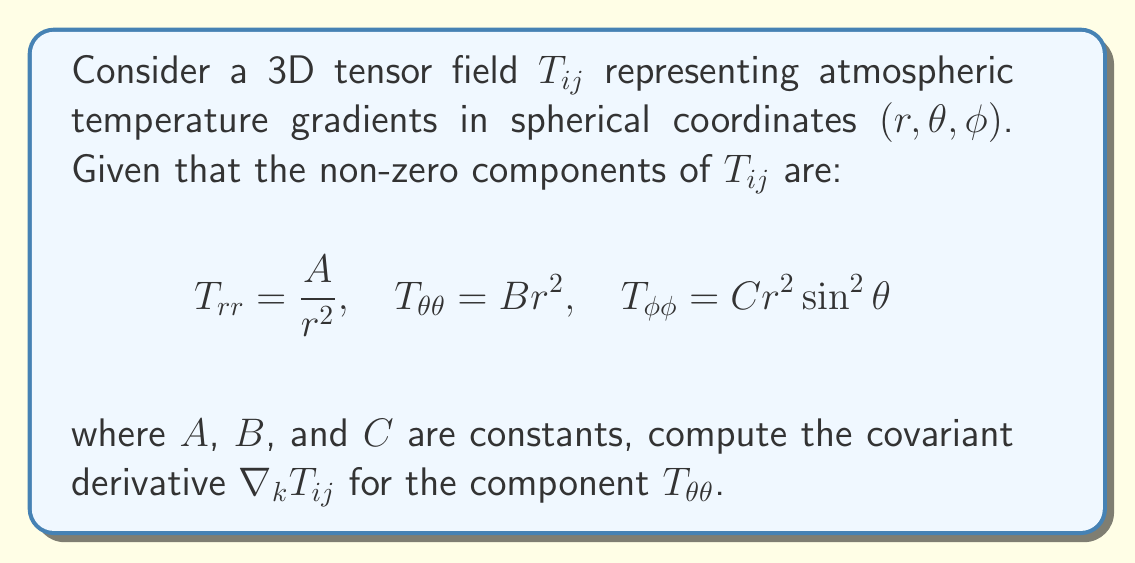Give your solution to this math problem. To compute the covariant derivative of $T_{\theta\theta}$, we use the formula:

$$\nabla_k T_{ij} = \partial_k T_{ij} + \Gamma^m_{ki}T_{mj} + \Gamma^m_{kj}T_{im}$$

where $\Gamma^m_{ij}$ are the Christoffel symbols.

Steps:
1) First, we need the non-zero Christoffel symbols for spherical coordinates:
   $$\Gamma^r_{\theta\theta} = -r, \quad \Gamma^\theta_{r\theta} = \Gamma^\theta_{\theta r} = \frac{1}{r}$$

2) Now, let's calculate each term:

   a) $\partial_k T_{\theta\theta}$:
      For $k = r$: $\partial_r T_{\theta\theta} = \partial_r (Br^2) = 2Br$
      For $k = \theta$ or $k = \phi$: $\partial_k T_{\theta\theta} = 0$

   b) $\Gamma^m_{ki}T_{mj}$:
      The only non-zero term is when $k = r$, $i = \theta$, $m = \theta$:
      $\Gamma^\theta_{r\theta}T_{\theta\theta} = \frac{1}{r} \cdot Br^2 = Br$

   c) $\Gamma^m_{kj}T_{im}$:
      This term is identical to (b) due to the symmetry of $T_{ij}$

3) Combining these terms:

   For $k = r$: $\nabla_r T_{\theta\theta} = 2Br + Br + Br = 4Br$
   For $k = \theta$ or $k = \phi$: $\nabla_k T_{\theta\theta} = 0$

Therefore, the non-zero component of the covariant derivative is $\nabla_r T_{\theta\theta} = 4Br$.
Answer: $\nabla_r T_{\theta\theta} = 4Br$, $\nabla_\theta T_{\theta\theta} = \nabla_\phi T_{\theta\theta} = 0$ 